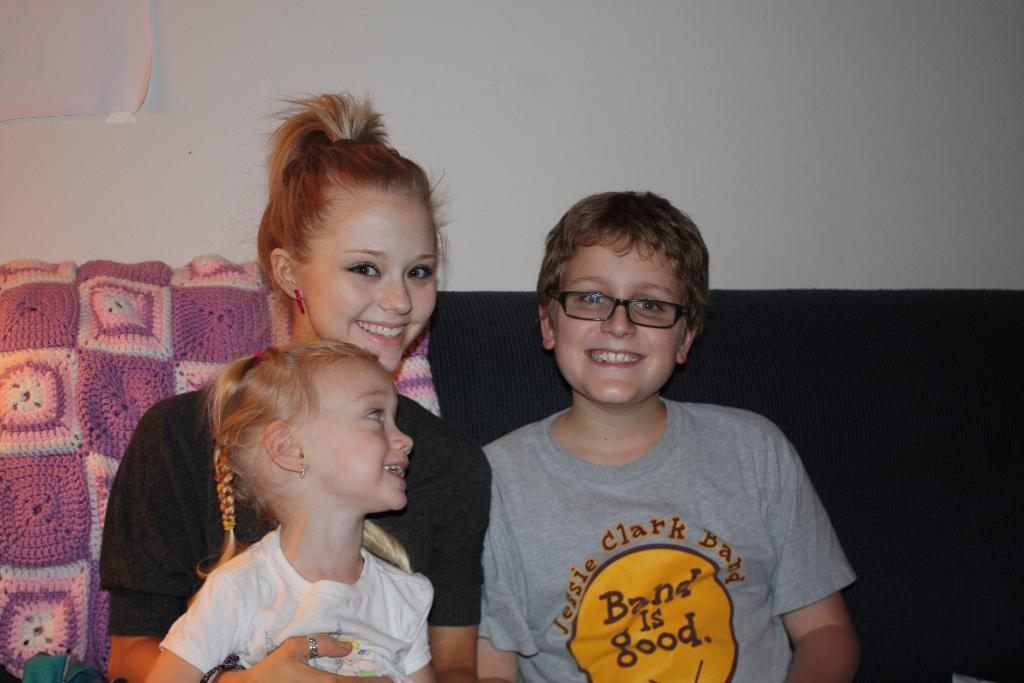How many people are in the image? There are three people in the image. What are the people doing in the image? The people are on a couch. What is covering the couch? There is a cloth on the couch. What color is the wall visible in the image? There is a white color wall visible in the image. Is there a scarecrow standing next to the couch in the image? No, there is no scarecrow present in the image. What type of chicken can be seen on the couch with the people? There are no chickens present in the image. 